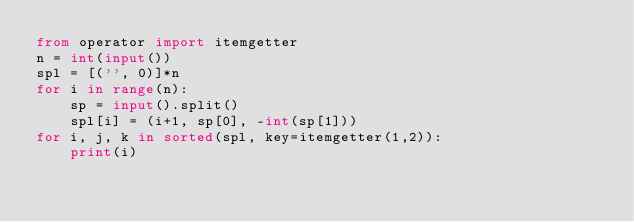<code> <loc_0><loc_0><loc_500><loc_500><_Python_>from operator import itemgetter
n = int(input())
spl = [('', 0)]*n
for i in range(n):
    sp = input().split()
    spl[i] = (i+1, sp[0], -int(sp[1]))
for i, j, k in sorted(spl, key=itemgetter(1,2)):
    print(i)</code> 